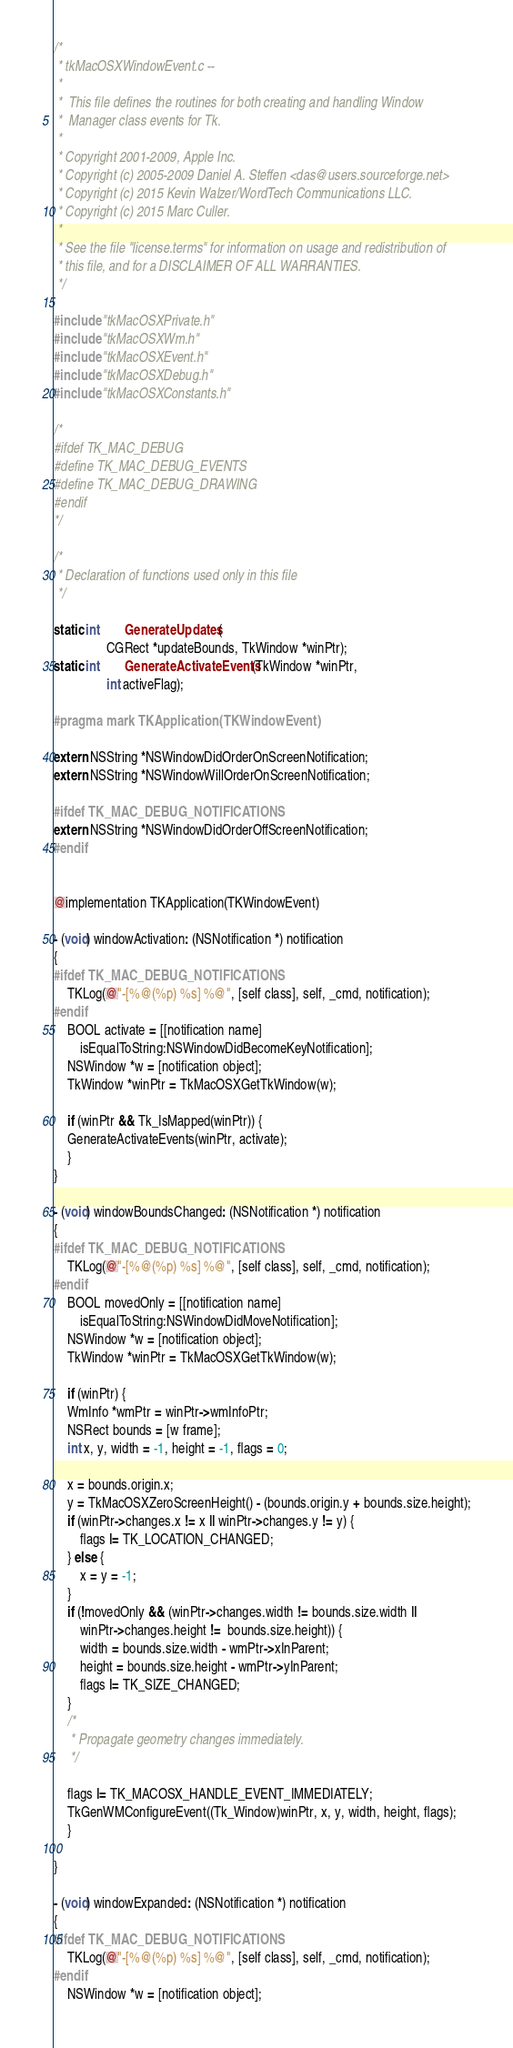<code> <loc_0><loc_0><loc_500><loc_500><_C_>/*
 * tkMacOSXWindowEvent.c --
 *
 *	This file defines the routines for both creating and handling Window
 *	Manager class events for Tk.
 *
 * Copyright 2001-2009, Apple Inc.
 * Copyright (c) 2005-2009 Daniel A. Steffen <das@users.sourceforge.net>
 * Copyright (c) 2015 Kevin Walzer/WordTech Communications LLC.
 * Copyright (c) 2015 Marc Culler.
 *
 * See the file "license.terms" for information on usage and redistribution of
 * this file, and for a DISCLAIMER OF ALL WARRANTIES.
 */

#include "tkMacOSXPrivate.h"
#include "tkMacOSXWm.h"
#include "tkMacOSXEvent.h"
#include "tkMacOSXDebug.h"
#include "tkMacOSXConstants.h"

/*
#ifdef TK_MAC_DEBUG
#define TK_MAC_DEBUG_EVENTS
#define TK_MAC_DEBUG_DRAWING
#endif
*/

/*
 * Declaration of functions used only in this file
 */

static int		GenerateUpdates(
			    CGRect *updateBounds, TkWindow *winPtr);
static int		GenerateActivateEvents(TkWindow *winPtr,
			    int activeFlag);

#pragma mark TKApplication(TKWindowEvent)

extern NSString *NSWindowDidOrderOnScreenNotification;
extern NSString *NSWindowWillOrderOnScreenNotification;

#ifdef TK_MAC_DEBUG_NOTIFICATIONS
extern NSString *NSWindowDidOrderOffScreenNotification;
#endif


@implementation TKApplication(TKWindowEvent)

- (void) windowActivation: (NSNotification *) notification
{
#ifdef TK_MAC_DEBUG_NOTIFICATIONS
    TKLog(@"-[%@(%p) %s] %@", [self class], self, _cmd, notification);
#endif
    BOOL activate = [[notification name]
	    isEqualToString:NSWindowDidBecomeKeyNotification];
    NSWindow *w = [notification object];
    TkWindow *winPtr = TkMacOSXGetTkWindow(w);

    if (winPtr && Tk_IsMapped(winPtr)) {
	GenerateActivateEvents(winPtr, activate);
    }
}

- (void) windowBoundsChanged: (NSNotification *) notification
{
#ifdef TK_MAC_DEBUG_NOTIFICATIONS
    TKLog(@"-[%@(%p) %s] %@", [self class], self, _cmd, notification);
#endif
    BOOL movedOnly = [[notification name]
	    isEqualToString:NSWindowDidMoveNotification];
    NSWindow *w = [notification object];
    TkWindow *winPtr = TkMacOSXGetTkWindow(w);

    if (winPtr) {
	WmInfo *wmPtr = winPtr->wmInfoPtr;
	NSRect bounds = [w frame];
	int x, y, width = -1, height = -1, flags = 0;

	x = bounds.origin.x;
	y = TkMacOSXZeroScreenHeight() - (bounds.origin.y + bounds.size.height);
	if (winPtr->changes.x != x || winPtr->changes.y != y) {
	    flags |= TK_LOCATION_CHANGED;
	} else {
	    x = y = -1;
	}
	if (!movedOnly && (winPtr->changes.width != bounds.size.width ||
		winPtr->changes.height !=  bounds.size.height)) {
	    width = bounds.size.width - wmPtr->xInParent;
	    height = bounds.size.height - wmPtr->yInParent;
	    flags |= TK_SIZE_CHANGED;
	}
	/*
	 * Propagate geometry changes immediately.
	 */

	flags |= TK_MACOSX_HANDLE_EVENT_IMMEDIATELY;
	TkGenWMConfigureEvent((Tk_Window)winPtr, x, y, width, height, flags);
    }

}

- (void) windowExpanded: (NSNotification *) notification
{
#ifdef TK_MAC_DEBUG_NOTIFICATIONS
    TKLog(@"-[%@(%p) %s] %@", [self class], self, _cmd, notification);
#endif
    NSWindow *w = [notification object];</code> 